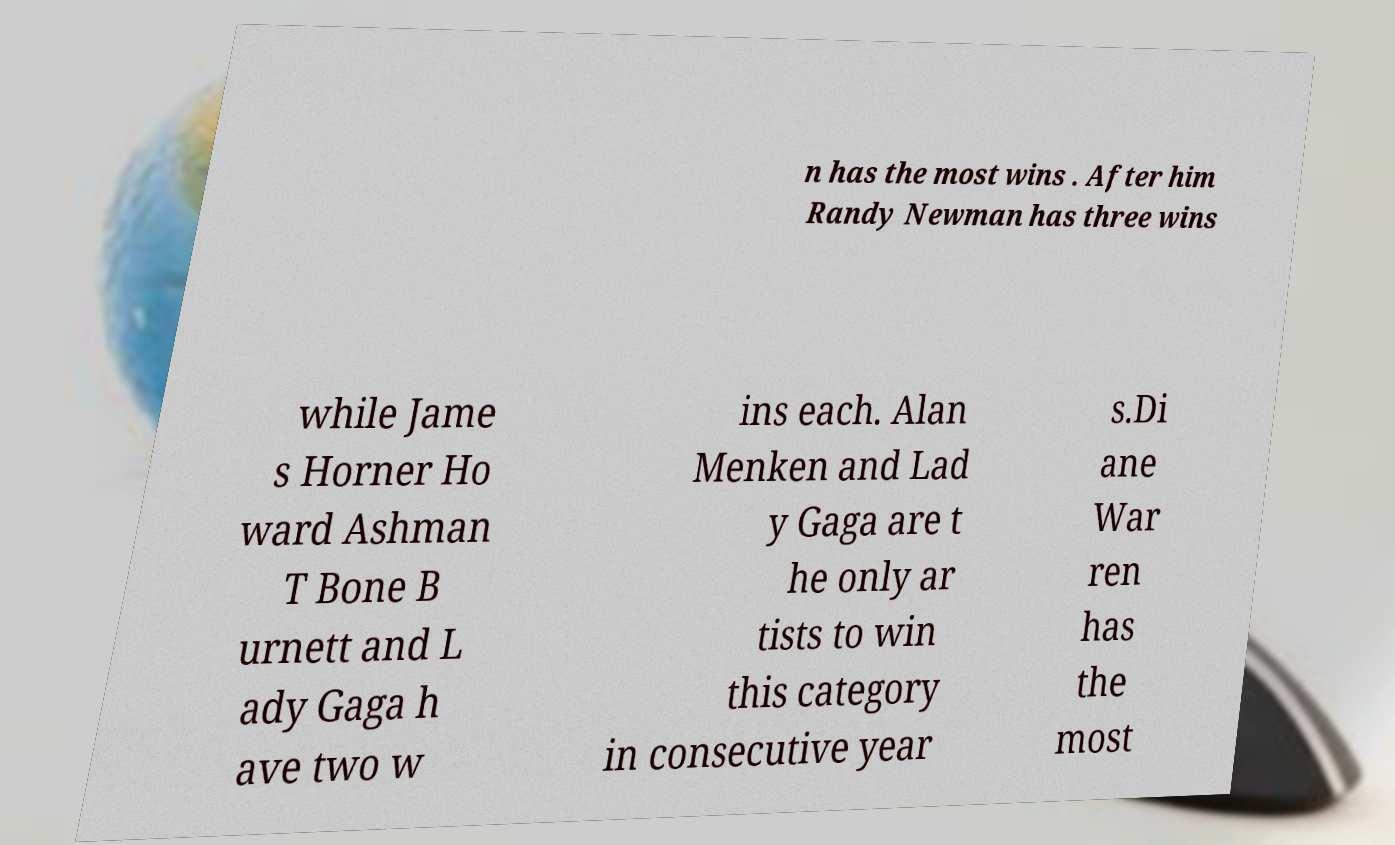Can you read and provide the text displayed in the image?This photo seems to have some interesting text. Can you extract and type it out for me? n has the most wins . After him Randy Newman has three wins while Jame s Horner Ho ward Ashman T Bone B urnett and L ady Gaga h ave two w ins each. Alan Menken and Lad y Gaga are t he only ar tists to win this category in consecutive year s.Di ane War ren has the most 